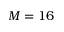<formula> <loc_0><loc_0><loc_500><loc_500>M = 1 6</formula> 